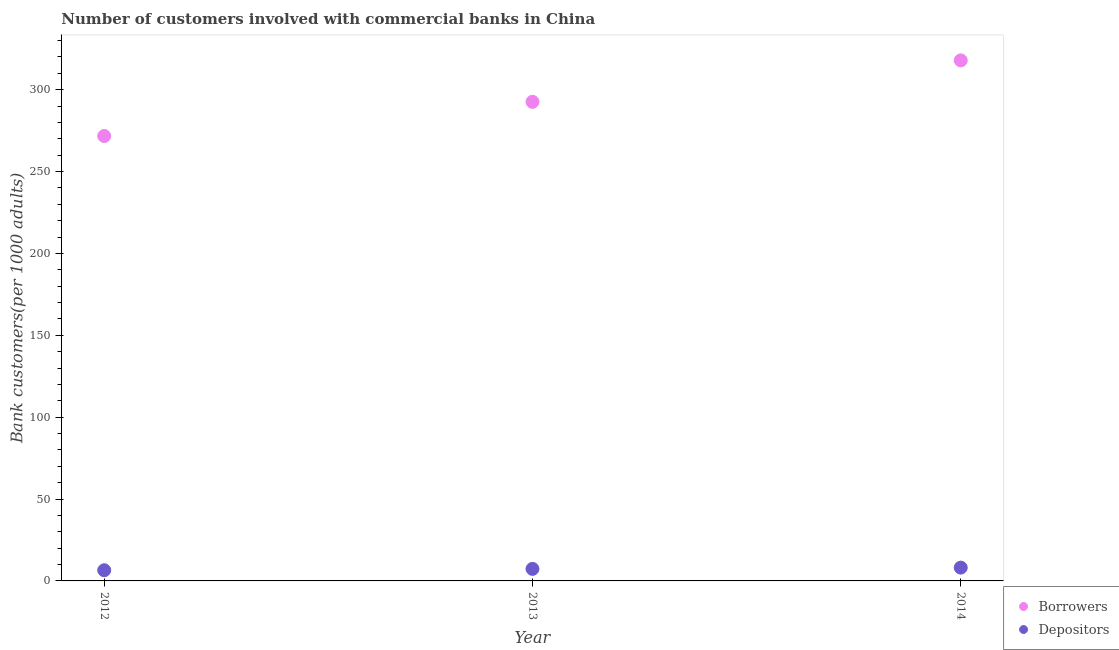Is the number of dotlines equal to the number of legend labels?
Keep it short and to the point. Yes. What is the number of depositors in 2012?
Provide a short and direct response. 6.52. Across all years, what is the maximum number of borrowers?
Your response must be concise. 317.9. Across all years, what is the minimum number of depositors?
Your answer should be compact. 6.52. What is the total number of borrowers in the graph?
Ensure brevity in your answer.  882.19. What is the difference between the number of borrowers in 2012 and that in 2014?
Your answer should be very brief. -46.19. What is the difference between the number of borrowers in 2013 and the number of depositors in 2012?
Ensure brevity in your answer.  286.06. What is the average number of depositors per year?
Ensure brevity in your answer.  7.33. In the year 2013, what is the difference between the number of borrowers and number of depositors?
Your answer should be very brief. 285.23. In how many years, is the number of depositors greater than 110?
Ensure brevity in your answer.  0. What is the ratio of the number of depositors in 2013 to that in 2014?
Your answer should be compact. 0.91. Is the number of depositors in 2013 less than that in 2014?
Offer a very short reply. Yes. What is the difference between the highest and the second highest number of borrowers?
Your response must be concise. 25.32. What is the difference between the highest and the lowest number of depositors?
Keep it short and to the point. 1.6. Is the sum of the number of depositors in 2012 and 2013 greater than the maximum number of borrowers across all years?
Provide a succinct answer. No. Does the number of borrowers monotonically increase over the years?
Give a very brief answer. Yes. Is the number of borrowers strictly less than the number of depositors over the years?
Offer a terse response. No. How many dotlines are there?
Offer a terse response. 2. How many years are there in the graph?
Provide a short and direct response. 3. What is the difference between two consecutive major ticks on the Y-axis?
Offer a very short reply. 50. Does the graph contain grids?
Give a very brief answer. No. Where does the legend appear in the graph?
Ensure brevity in your answer.  Bottom right. How are the legend labels stacked?
Your response must be concise. Vertical. What is the title of the graph?
Offer a very short reply. Number of customers involved with commercial banks in China. Does "Private funds" appear as one of the legend labels in the graph?
Your answer should be very brief. No. What is the label or title of the X-axis?
Give a very brief answer. Year. What is the label or title of the Y-axis?
Your answer should be very brief. Bank customers(per 1000 adults). What is the Bank customers(per 1000 adults) of Borrowers in 2012?
Provide a short and direct response. 271.71. What is the Bank customers(per 1000 adults) of Depositors in 2012?
Ensure brevity in your answer.  6.52. What is the Bank customers(per 1000 adults) in Borrowers in 2013?
Provide a short and direct response. 292.58. What is the Bank customers(per 1000 adults) of Depositors in 2013?
Offer a very short reply. 7.35. What is the Bank customers(per 1000 adults) in Borrowers in 2014?
Offer a terse response. 317.9. What is the Bank customers(per 1000 adults) of Depositors in 2014?
Your response must be concise. 8.12. Across all years, what is the maximum Bank customers(per 1000 adults) in Borrowers?
Provide a short and direct response. 317.9. Across all years, what is the maximum Bank customers(per 1000 adults) of Depositors?
Your answer should be very brief. 8.12. Across all years, what is the minimum Bank customers(per 1000 adults) in Borrowers?
Give a very brief answer. 271.71. Across all years, what is the minimum Bank customers(per 1000 adults) in Depositors?
Make the answer very short. 6.52. What is the total Bank customers(per 1000 adults) in Borrowers in the graph?
Your response must be concise. 882.19. What is the total Bank customers(per 1000 adults) in Depositors in the graph?
Give a very brief answer. 21.99. What is the difference between the Bank customers(per 1000 adults) of Borrowers in 2012 and that in 2013?
Provide a short and direct response. -20.87. What is the difference between the Bank customers(per 1000 adults) of Depositors in 2012 and that in 2013?
Keep it short and to the point. -0.83. What is the difference between the Bank customers(per 1000 adults) of Borrowers in 2012 and that in 2014?
Ensure brevity in your answer.  -46.19. What is the difference between the Bank customers(per 1000 adults) in Depositors in 2012 and that in 2014?
Keep it short and to the point. -1.6. What is the difference between the Bank customers(per 1000 adults) of Borrowers in 2013 and that in 2014?
Provide a succinct answer. -25.32. What is the difference between the Bank customers(per 1000 adults) in Depositors in 2013 and that in 2014?
Offer a very short reply. -0.77. What is the difference between the Bank customers(per 1000 adults) of Borrowers in 2012 and the Bank customers(per 1000 adults) of Depositors in 2013?
Offer a very short reply. 264.36. What is the difference between the Bank customers(per 1000 adults) in Borrowers in 2012 and the Bank customers(per 1000 adults) in Depositors in 2014?
Your answer should be compact. 263.59. What is the difference between the Bank customers(per 1000 adults) of Borrowers in 2013 and the Bank customers(per 1000 adults) of Depositors in 2014?
Ensure brevity in your answer.  284.46. What is the average Bank customers(per 1000 adults) in Borrowers per year?
Give a very brief answer. 294.06. What is the average Bank customers(per 1000 adults) of Depositors per year?
Keep it short and to the point. 7.33. In the year 2012, what is the difference between the Bank customers(per 1000 adults) of Borrowers and Bank customers(per 1000 adults) of Depositors?
Give a very brief answer. 265.19. In the year 2013, what is the difference between the Bank customers(per 1000 adults) of Borrowers and Bank customers(per 1000 adults) of Depositors?
Your response must be concise. 285.23. In the year 2014, what is the difference between the Bank customers(per 1000 adults) in Borrowers and Bank customers(per 1000 adults) in Depositors?
Ensure brevity in your answer.  309.78. What is the ratio of the Bank customers(per 1000 adults) of Borrowers in 2012 to that in 2013?
Make the answer very short. 0.93. What is the ratio of the Bank customers(per 1000 adults) of Depositors in 2012 to that in 2013?
Provide a short and direct response. 0.89. What is the ratio of the Bank customers(per 1000 adults) of Borrowers in 2012 to that in 2014?
Keep it short and to the point. 0.85. What is the ratio of the Bank customers(per 1000 adults) of Depositors in 2012 to that in 2014?
Your answer should be compact. 0.8. What is the ratio of the Bank customers(per 1000 adults) of Borrowers in 2013 to that in 2014?
Make the answer very short. 0.92. What is the ratio of the Bank customers(per 1000 adults) of Depositors in 2013 to that in 2014?
Make the answer very short. 0.91. What is the difference between the highest and the second highest Bank customers(per 1000 adults) in Borrowers?
Your response must be concise. 25.32. What is the difference between the highest and the second highest Bank customers(per 1000 adults) in Depositors?
Keep it short and to the point. 0.77. What is the difference between the highest and the lowest Bank customers(per 1000 adults) in Borrowers?
Your answer should be very brief. 46.19. What is the difference between the highest and the lowest Bank customers(per 1000 adults) of Depositors?
Keep it short and to the point. 1.6. 